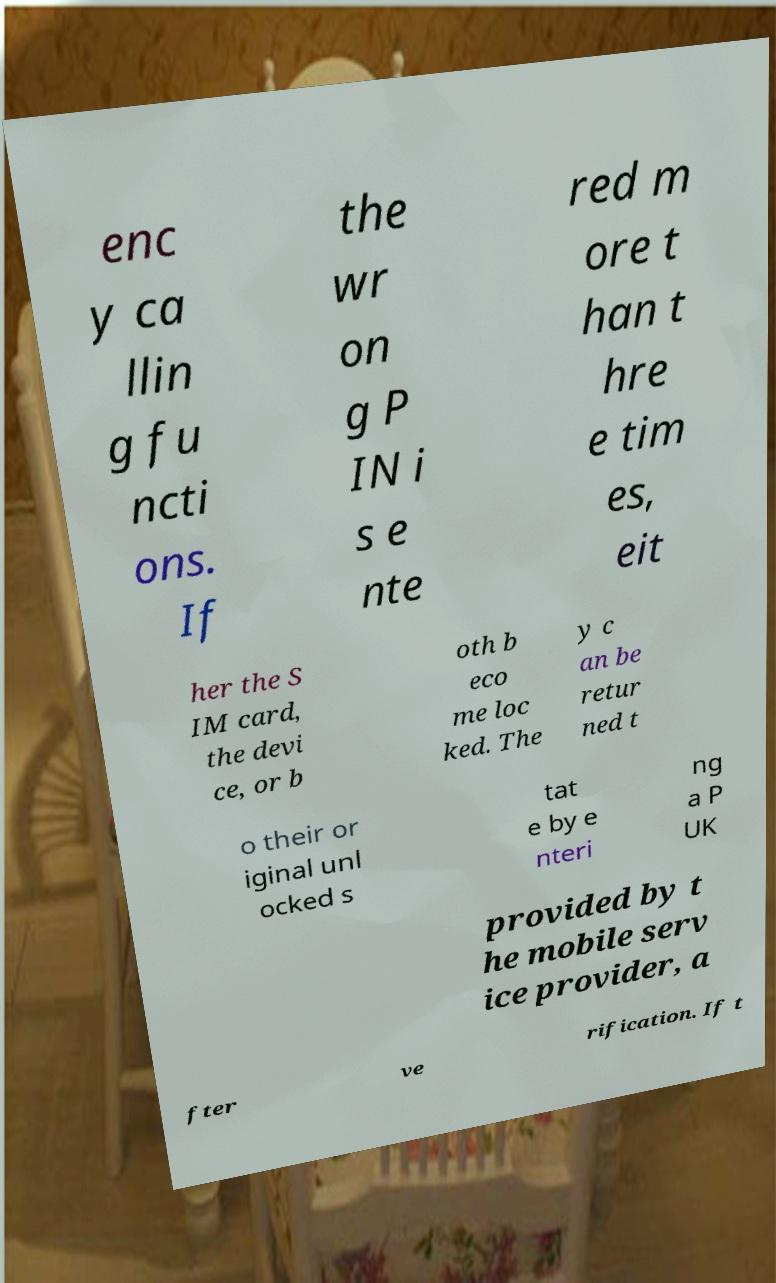Could you extract and type out the text from this image? enc y ca llin g fu ncti ons. If the wr on g P IN i s e nte red m ore t han t hre e tim es, eit her the S IM card, the devi ce, or b oth b eco me loc ked. The y c an be retur ned t o their or iginal unl ocked s tat e by e nteri ng a P UK provided by t he mobile serv ice provider, a fter ve rification. If t 